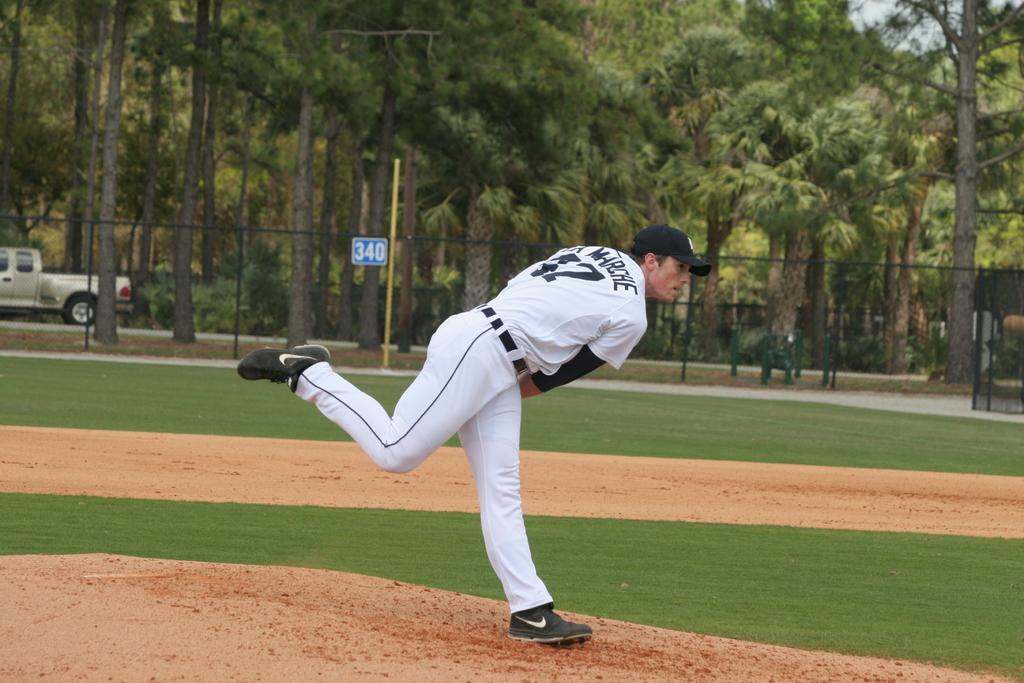<image>
Summarize the visual content of the image. a person on the baseball field with the number 340 in the background 